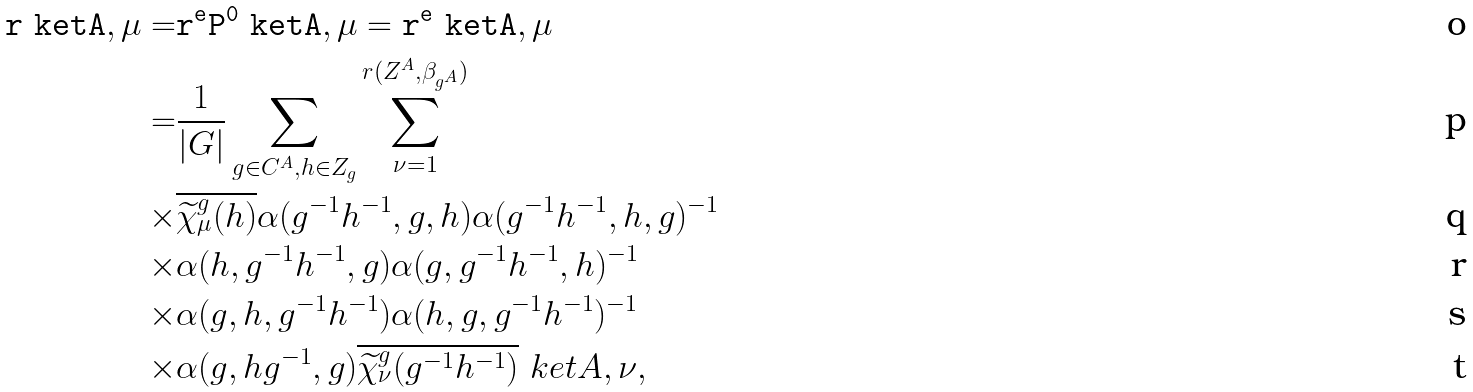<formula> <loc_0><loc_0><loc_500><loc_500>\tt r \ k e t { A , \mu } = & \tt r ^ { e } P ^ { 0 } \ k e t { A , \mu } = \tt r ^ { e } \ k e t { A , \mu } \\ = & \frac { 1 } { | G | } \sum _ { g \in C ^ { A } , h \in Z _ { g } } \sum _ { \nu = 1 } ^ { r ( Z ^ { A } , \beta _ { g ^ { A } } ) } \\ \times & \overline { \widetilde { \chi } ^ { g } _ { \mu } ( h ) } \alpha ( g ^ { - 1 } h ^ { - 1 } , g , h ) \alpha ( g ^ { - 1 } h ^ { - 1 } , h , g ) ^ { - 1 } \\ \times & \alpha ( h , g ^ { - 1 } h ^ { - 1 } , g ) \alpha ( g , g ^ { - 1 } h ^ { - 1 } , h ) ^ { - 1 } \\ \times & \alpha ( g , h , g ^ { - 1 } h ^ { - 1 } ) \alpha ( h , g , g ^ { - 1 } h ^ { - 1 } ) ^ { - 1 } \\ \times & \alpha ( g , h g ^ { - 1 } , g ) \overline { \widetilde { \chi } ^ { g } _ { \nu } ( g ^ { - 1 } h ^ { - 1 } ) } \ k e t { A , \nu } ,</formula> 